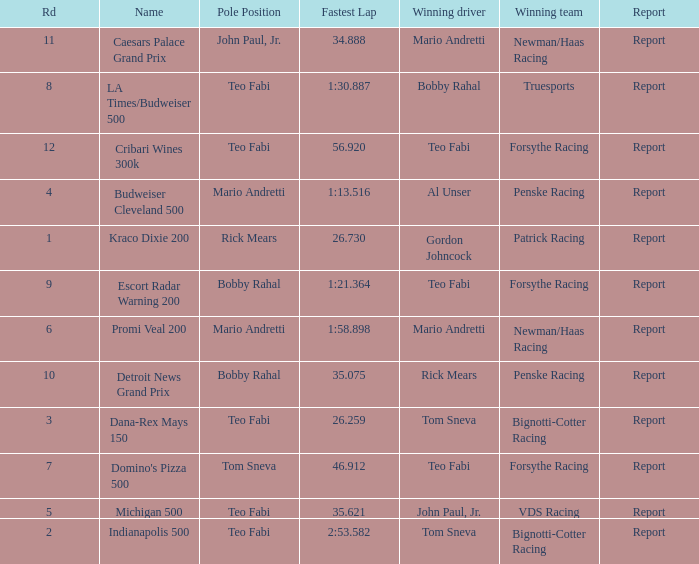Which teams won when Bobby Rahal was their winning driver? Truesports. 